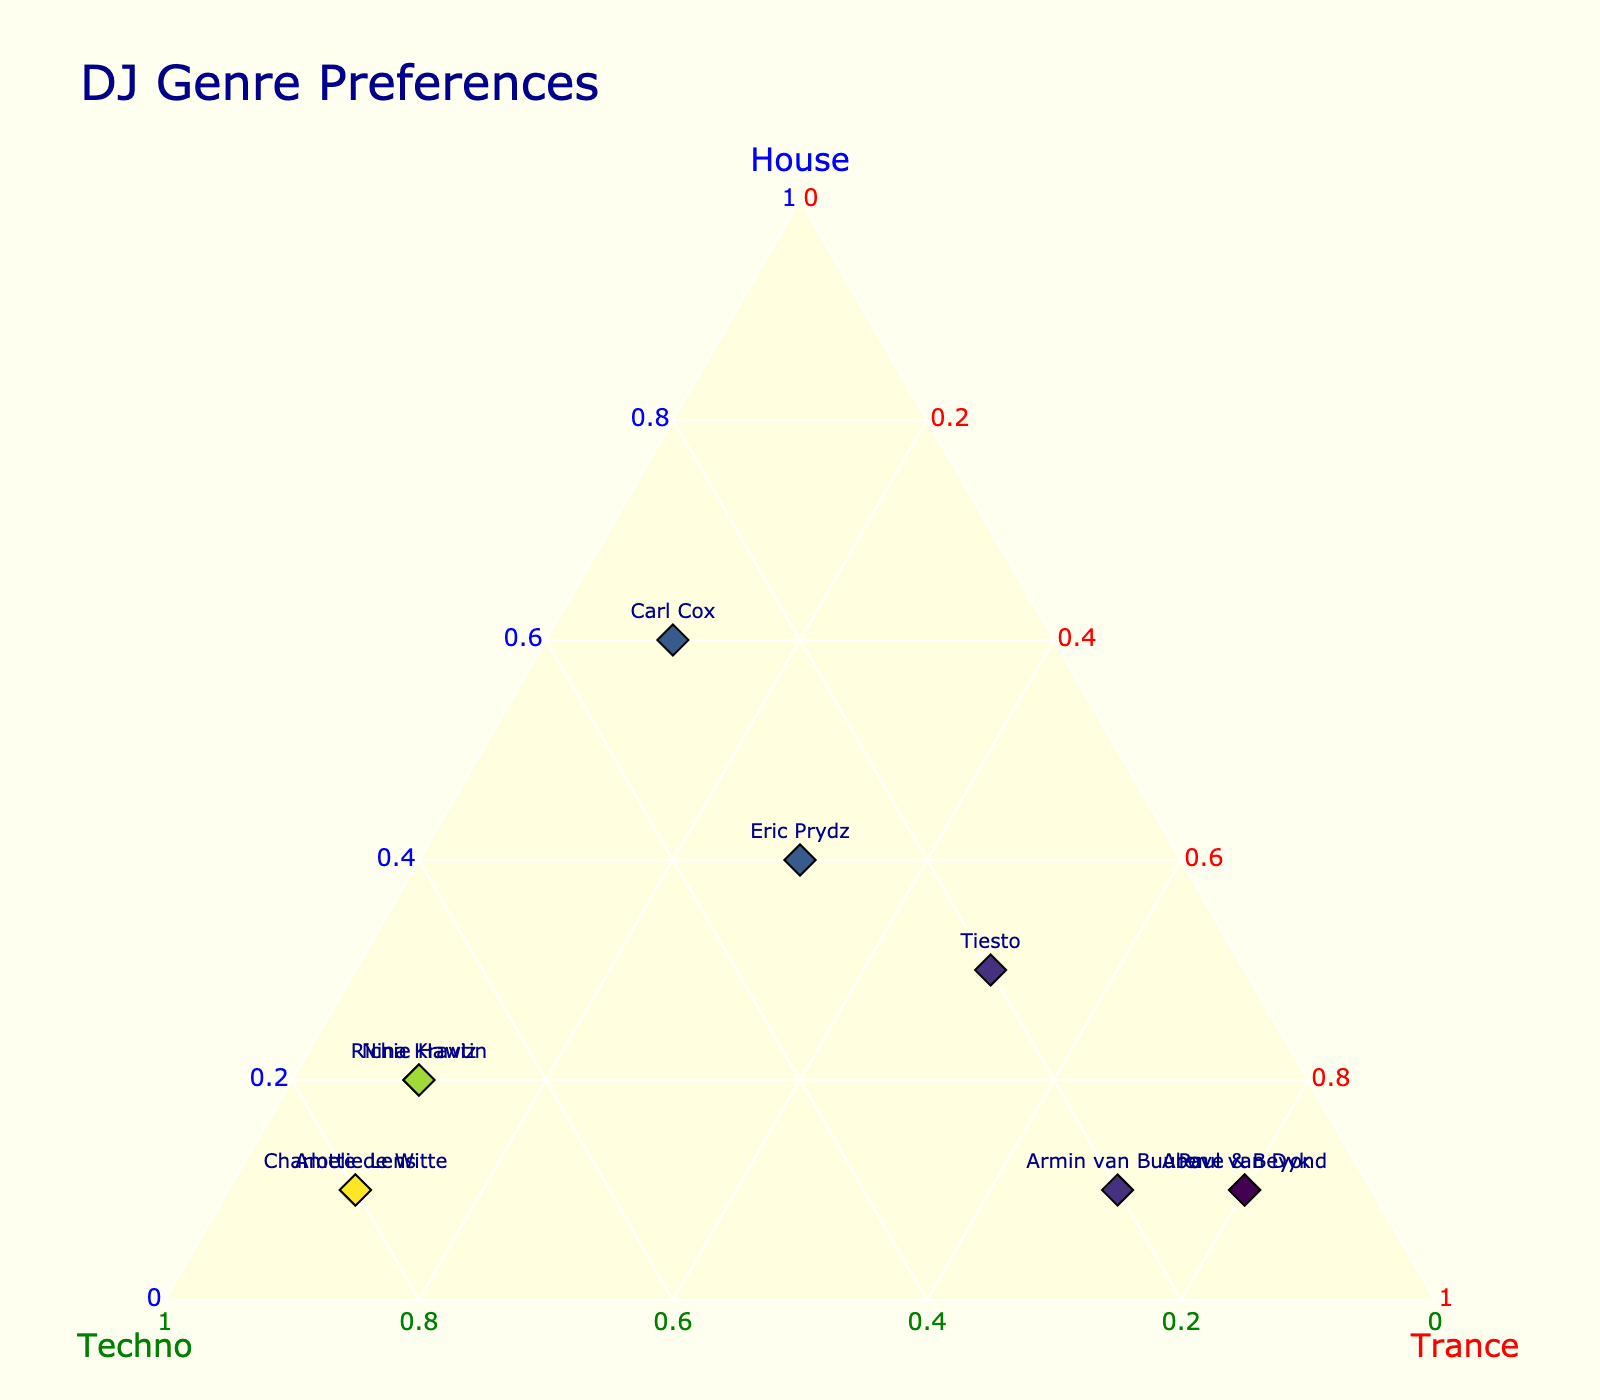What is the title of the figure? The title of the figure is located at the top and states the overall theme or subject of the plot.
Answer: DJ Genre Preferences How many DJs are represented in the plot? Each DJ is indicated by a marker labeled with their name, count the number of distinct markers.
Answer: 10 Which DJ prefers Techno the most? Look for the DJ whose marker is closest to the Techno axis with the highest value.
Answer: Charlotte de Witte What is the color of the background for the ternary plot? The background color of the ternary part of the plot is specified for visual distinction.
Answer: Light yellow Which genre does Tiesto prefer the most? Examine where Tiesto's marker is positioned relative to the axes. See which axis label it is closest to.
Answer: Trance How many DJs have a House preference of at least 0.4? Look at the markers and count how many are placed at a position where the House value is 0.4 or higher.
Answer: 2 Who has an equal preference for Techno and Trance? Check the coordinates for the DJ who has the same value for both Techno and Trance.
Answer: Eric Prydz Which DJs have the same preference values in House and Trance? Identify the DJs whose positions in the ternary plot show identical values for House and Trance.
Answer: None Who has the lowest preference for House? Find the DJ whose marker is closest to the Techno and Trance axes indicating a lower House value.
Answer: Paul van Dyk What is the average preference value for Trance among all DJs? Add up the Trance values for each DJ and divide by the number of DJs: (0.1+0.7+0.1+0.5+0.1+0.8+0.1+0.3+0.1+0.8)/10.
Answer: 0.35 